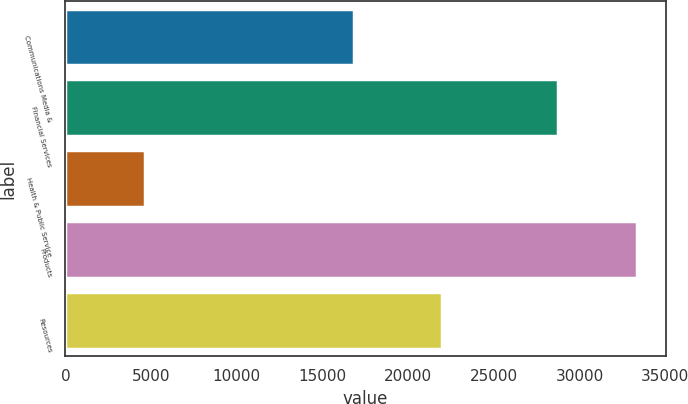Convert chart to OTSL. <chart><loc_0><loc_0><loc_500><loc_500><bar_chart><fcel>Communications Media &<fcel>Financial Services<fcel>Health & Public Service<fcel>Products<fcel>Resources<nl><fcel>16828<fcel>28723<fcel>4620<fcel>33364<fcel>21962<nl></chart> 